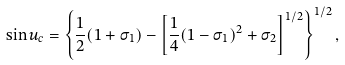Convert formula to latex. <formula><loc_0><loc_0><loc_500><loc_500>\sin u _ { c } = \left \{ \frac { 1 } { 2 } ( 1 + \sigma _ { 1 } ) - \left [ \frac { 1 } { 4 } ( 1 - \sigma _ { 1 } ) ^ { 2 } + \sigma _ { 2 } \right ] ^ { 1 / 2 } \right \} ^ { 1 / 2 } ,</formula> 